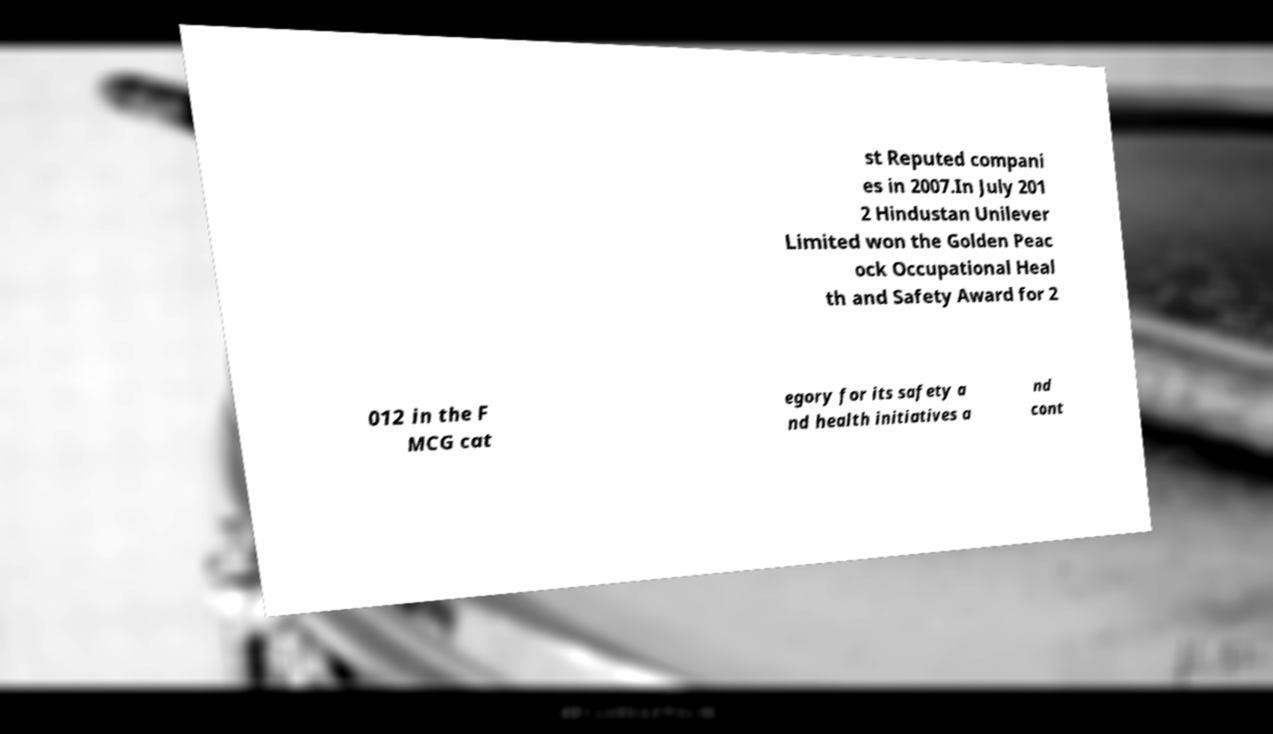What messages or text are displayed in this image? I need them in a readable, typed format. st Reputed compani es in 2007.In July 201 2 Hindustan Unilever Limited won the Golden Peac ock Occupational Heal th and Safety Award for 2 012 in the F MCG cat egory for its safety a nd health initiatives a nd cont 